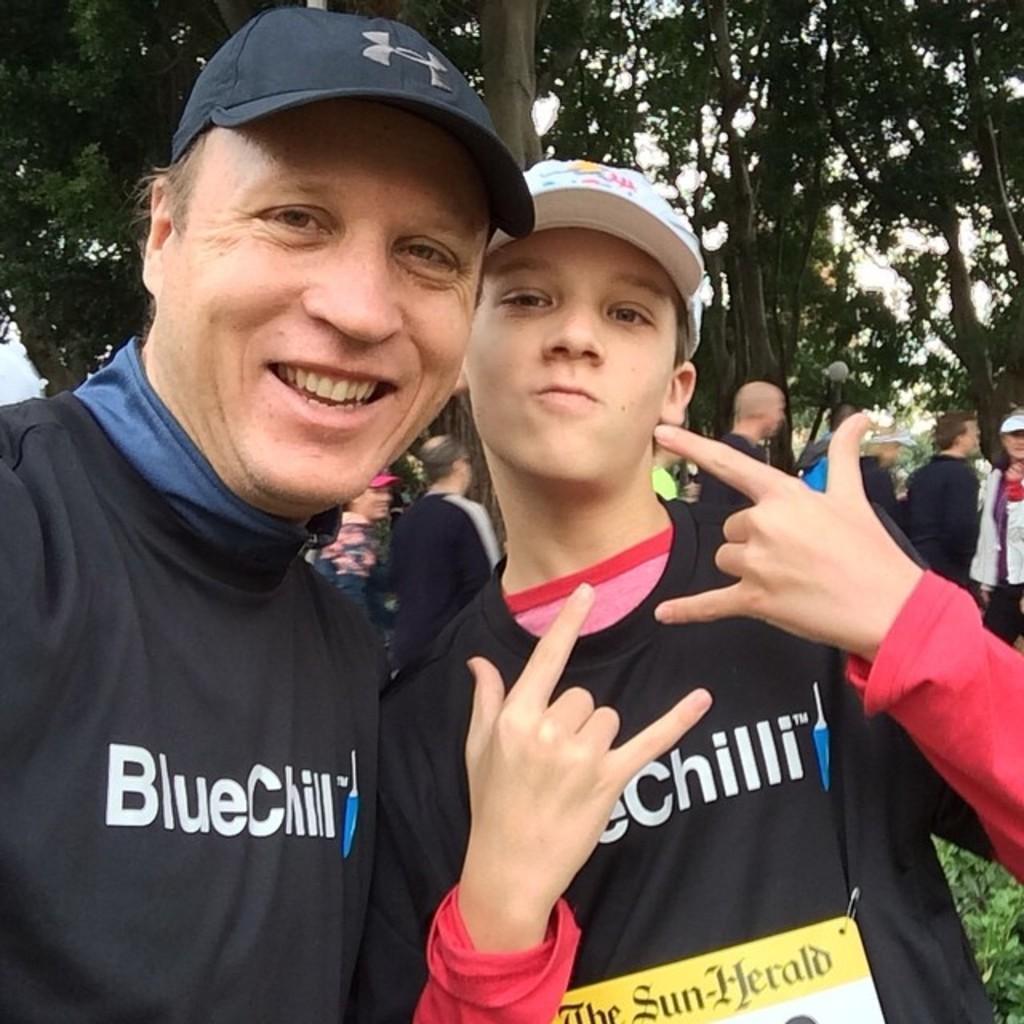Describe this image in one or two sentences. In this image we can see a group of people standing on the ground. On the right side of the image we can see some plants. At the top of the image we can see a group of trees. 